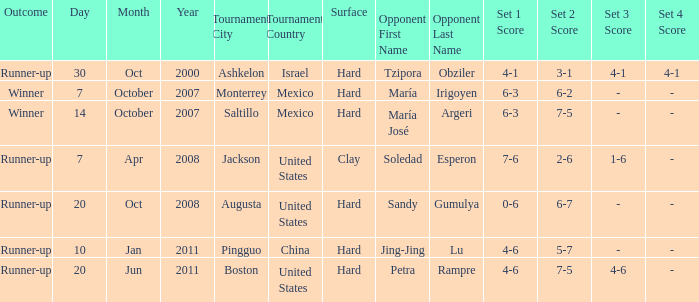Who was the opponent with a score of 4-6, 7-5, 4-6? Petra Rampre. 